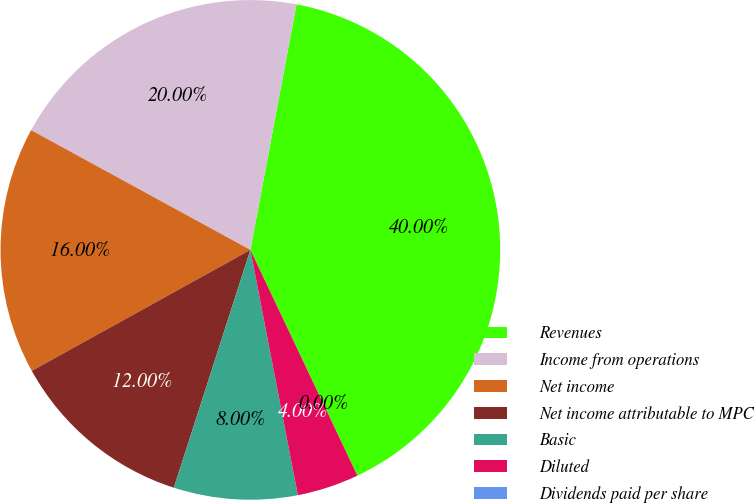Convert chart. <chart><loc_0><loc_0><loc_500><loc_500><pie_chart><fcel>Revenues<fcel>Income from operations<fcel>Net income<fcel>Net income attributable to MPC<fcel>Basic<fcel>Diluted<fcel>Dividends paid per share<nl><fcel>40.0%<fcel>20.0%<fcel>16.0%<fcel>12.0%<fcel>8.0%<fcel>4.0%<fcel>0.0%<nl></chart> 